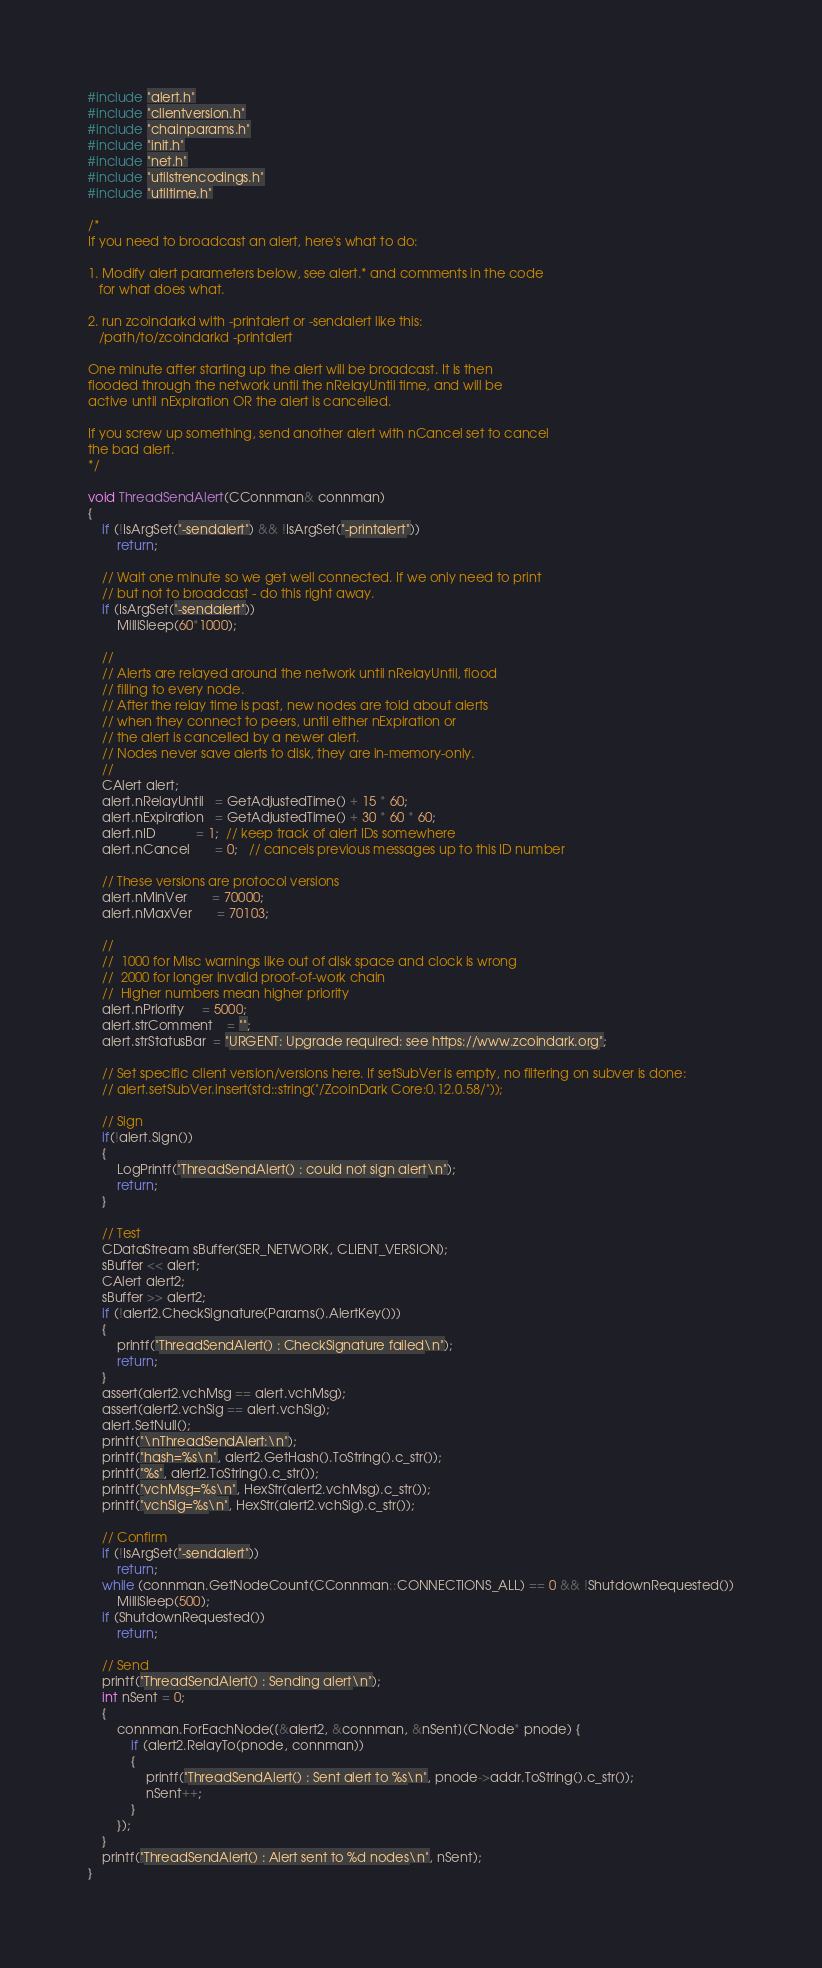<code> <loc_0><loc_0><loc_500><loc_500><_C++_>#include "alert.h"
#include "clientversion.h"
#include "chainparams.h"
#include "init.h"
#include "net.h"
#include "utilstrencodings.h"
#include "utiltime.h"

/*
If you need to broadcast an alert, here's what to do:

1. Modify alert parameters below, see alert.* and comments in the code
   for what does what.

2. run zcoindarkd with -printalert or -sendalert like this:
   /path/to/zcoindarkd -printalert

One minute after starting up the alert will be broadcast. It is then
flooded through the network until the nRelayUntil time, and will be
active until nExpiration OR the alert is cancelled.

If you screw up something, send another alert with nCancel set to cancel
the bad alert.
*/

void ThreadSendAlert(CConnman& connman)
{
    if (!IsArgSet("-sendalert") && !IsArgSet("-printalert"))
        return;

    // Wait one minute so we get well connected. If we only need to print
    // but not to broadcast - do this right away.
    if (IsArgSet("-sendalert"))
        MilliSleep(60*1000);

    //
    // Alerts are relayed around the network until nRelayUntil, flood
    // filling to every node.
    // After the relay time is past, new nodes are told about alerts
    // when they connect to peers, until either nExpiration or
    // the alert is cancelled by a newer alert.
    // Nodes never save alerts to disk, they are in-memory-only.
    //
    CAlert alert;
    alert.nRelayUntil   = GetAdjustedTime() + 15 * 60;
    alert.nExpiration   = GetAdjustedTime() + 30 * 60 * 60;
    alert.nID           = 1;  // keep track of alert IDs somewhere
    alert.nCancel       = 0;   // cancels previous messages up to this ID number

    // These versions are protocol versions
    alert.nMinVer       = 70000;
    alert.nMaxVer       = 70103;

    //
    //  1000 for Misc warnings like out of disk space and clock is wrong
    //  2000 for longer invalid proof-of-work chain
    //  Higher numbers mean higher priority
    alert.nPriority     = 5000;
    alert.strComment    = "";
    alert.strStatusBar  = "URGENT: Upgrade required: see https://www.zcoindark.org";

    // Set specific client version/versions here. If setSubVer is empty, no filtering on subver is done:
    // alert.setSubVer.insert(std::string("/ZcoinDark Core:0.12.0.58/"));

    // Sign
    if(!alert.Sign())
    {
        LogPrintf("ThreadSendAlert() : could not sign alert\n");
        return;
    }

    // Test
    CDataStream sBuffer(SER_NETWORK, CLIENT_VERSION);
    sBuffer << alert;
    CAlert alert2;
    sBuffer >> alert2;
    if (!alert2.CheckSignature(Params().AlertKey()))
    {
        printf("ThreadSendAlert() : CheckSignature failed\n");
        return;
    }
    assert(alert2.vchMsg == alert.vchMsg);
    assert(alert2.vchSig == alert.vchSig);
    alert.SetNull();
    printf("\nThreadSendAlert:\n");
    printf("hash=%s\n", alert2.GetHash().ToString().c_str());
    printf("%s", alert2.ToString().c_str());
    printf("vchMsg=%s\n", HexStr(alert2.vchMsg).c_str());
    printf("vchSig=%s\n", HexStr(alert2.vchSig).c_str());

    // Confirm
    if (!IsArgSet("-sendalert"))
        return;
    while (connman.GetNodeCount(CConnman::CONNECTIONS_ALL) == 0 && !ShutdownRequested())
        MilliSleep(500);
    if (ShutdownRequested())
        return;

    // Send
    printf("ThreadSendAlert() : Sending alert\n");
    int nSent = 0;
    {
        connman.ForEachNode([&alert2, &connman, &nSent](CNode* pnode) {
            if (alert2.RelayTo(pnode, connman))
            {
                printf("ThreadSendAlert() : Sent alert to %s\n", pnode->addr.ToString().c_str());
                nSent++;
            }
        });
    }
    printf("ThreadSendAlert() : Alert sent to %d nodes\n", nSent);
}
</code> 